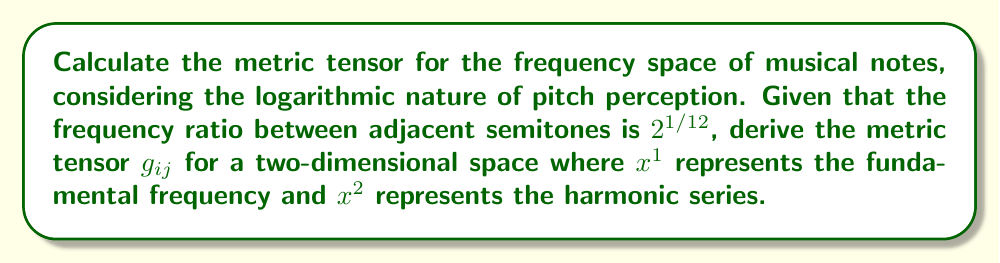Provide a solution to this math problem. To compute the metric tensor for the frequency space of musical notes, we'll follow these steps:

1) First, let's define our coordinate system:
   $x^1$: fundamental frequency (in Hz)
   $x^2$: harmonic number (integer ≥ 1)

2) The frequency of any note in this space can be expressed as:
   $$f(x^1, x^2) = x^1 \cdot x^2$$

3) To account for the logarithmic nature of pitch perception, we need to work with the logarithm of frequency. Let's define:
   $$y = \log_2(f) = \log_2(x^1) + \log_2(x^2)$$

4) Now, we need to compute the partial derivatives:
   $$\frac{\partial y}{\partial x^1} = \frac{1}{x^1 \ln 2}$$
   $$\frac{\partial y}{\partial x^2} = \frac{1}{x^2 \ln 2}$$

5) The metric tensor $g_{ij}$ is defined as:
   $$g_{ij} = \frac{\partial y}{\partial x^i} \frac{\partial y}{\partial x^j}$$

6) Computing the components:
   $$g_{11} = (\frac{\partial y}{\partial x^1})^2 = \frac{1}{(x^1 \ln 2)^2}$$
   $$g_{22} = (\frac{\partial y}{\partial x^2})^2 = \frac{1}{(x^2 \ln 2)^2}$$
   $$g_{12} = g_{21} = \frac{\partial y}{\partial x^1} \frac{\partial y}{\partial x^2} = \frac{1}{x^1 x^2 (\ln 2)^2}$$

7) Therefore, the metric tensor is:
   $$g_{ij} = \begin{pmatrix} 
   \frac{1}{(x^1 \ln 2)^2} & \frac{1}{x^1 x^2 (\ln 2)^2} \\
   \frac{1}{x^1 x^2 (\ln 2)^2} & \frac{1}{(x^2 \ln 2)^2}
   \end{pmatrix}$$

This metric tensor describes the geometry of the frequency space, taking into account the logarithmic nature of pitch perception and the relationship between fundamental frequencies and their harmonics.
Answer: $$g_{ij} = \begin{pmatrix} 
\frac{1}{(x^1 \ln 2)^2} & \frac{1}{x^1 x^2 (\ln 2)^2} \\
\frac{1}{x^1 x^2 (\ln 2)^2} & \frac{1}{(x^2 \ln 2)^2}
\end{pmatrix}$$ 